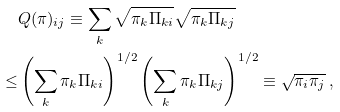<formula> <loc_0><loc_0><loc_500><loc_500>& Q ( \pi ) _ { i j } \equiv \sum _ { k } \sqrt { \pi _ { k } \Pi _ { k i } } \sqrt { \pi _ { k } \Pi _ { k j } } \\ \leq & \left ( \sum _ { k } \pi _ { k } \Pi _ { k i } \right ) ^ { 1 / 2 } \left ( \sum _ { k } \pi _ { k } \Pi _ { k j } \right ) ^ { 1 / 2 } \equiv \sqrt { \pi _ { i } \pi _ { j } } \, ,</formula> 